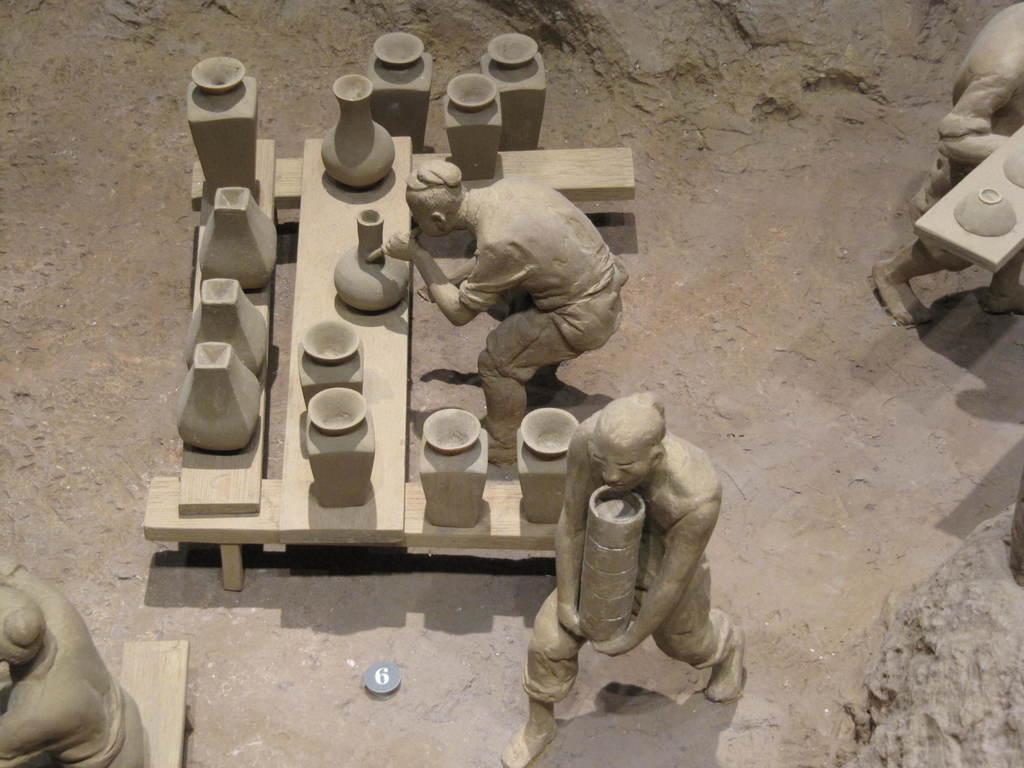Please provide a concise description of this image. In this image I can see few statues and I can see few bowls on the cream color surface. 